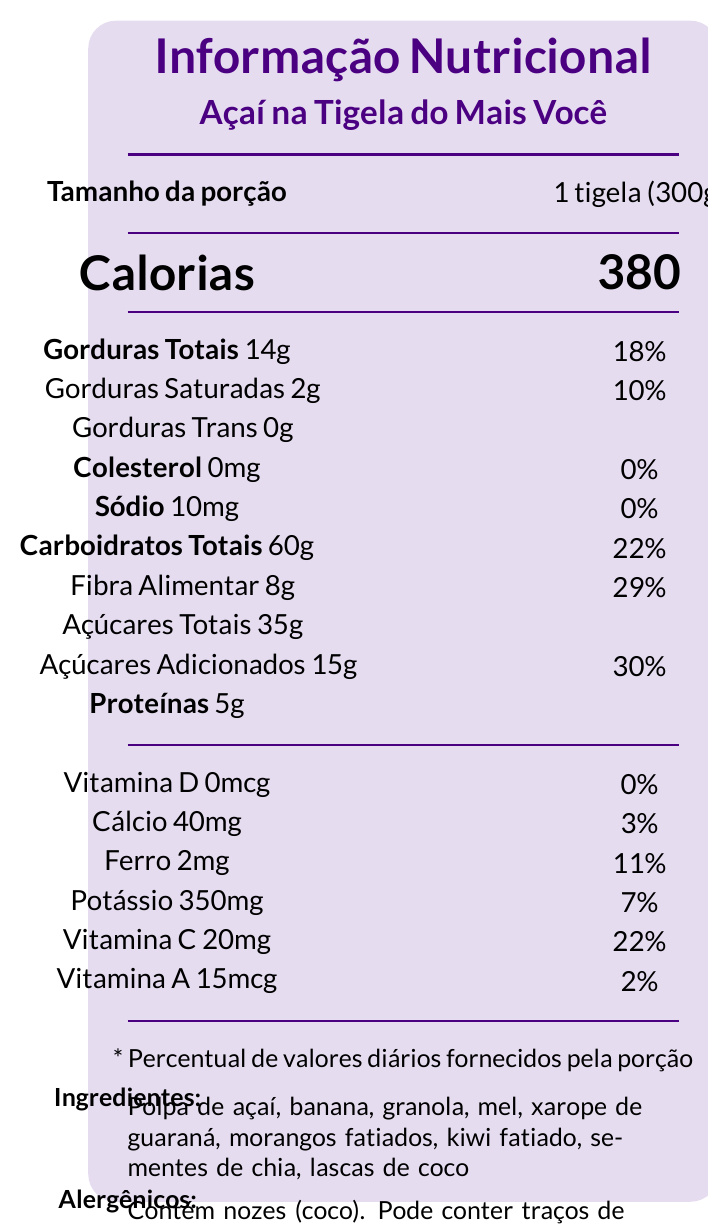what is the serving size for the Açaí na Tigela do Mais Você? The serving size is explicitly mentioned as 1 bowl (300g) in the document.
Answer: 1 bowl (300g) how many calories are in one serving of the Açaí na Tigela do Mais Você? The document lists the calorie content per serving as 380 calories.
Answer: 380 what are the main ingredients of the Açaí na Tigela do Mais Você? The ingredients are listed in the ingredients section of the document.
Answer: Açaí pulp, banana, granola, honey, guaraná syrup, sliced strawberries, sliced kiwi, chia seeds, coconut flakes how much protein does one serving contain? The document states that one serving contains 5 grams of protein.
Answer: 5g who is the host of the show where this açaí bowl was featured? The host is Ana Maria Braga, as mentioned in the show information section.
Answer: Ana Maria Braga  Vitamin C is present at 22% of the daily value, which is higher than the percentages for other vitamins and minerals listed.
Answer: D. Vitamin C  The health claims in the document are "Rico em fibras" (High in fibers), "Fonte de antioxidantes" (Source of antioxidants), and "Livre de gorduras trans" (Free of trans fats).
Answer: A. I, II, III are tree nuts contained in the açaí bowl? The document states that it contains tree nuts, specifically coconut.
Answer: Yes can the level of cholesterol in the açaí bowl be determined from the document? The document specifies that the açaí bowl contains 0mg of cholesterol.
Answer: Yes describe the main idea of the document. This summary includes the crucial points – nutritional facts, ingredients, allergen information, health claims, and its appearance on the "Mais Você" talk show.
Answer: The document presents nutritional information, ingredients, allergen warnings, and health claims for an açaí bowl named "Açaí na Tigela do Mais Você." The açaí bowl was featured on a segment of the "Mais Você" talk show hosted by Ana Maria Braga. what is the main source of sodium in the açaí bowl? The document mentions the sodium content but does not specify the ingredient that contributes to sodium.
Answer: I don't know. 